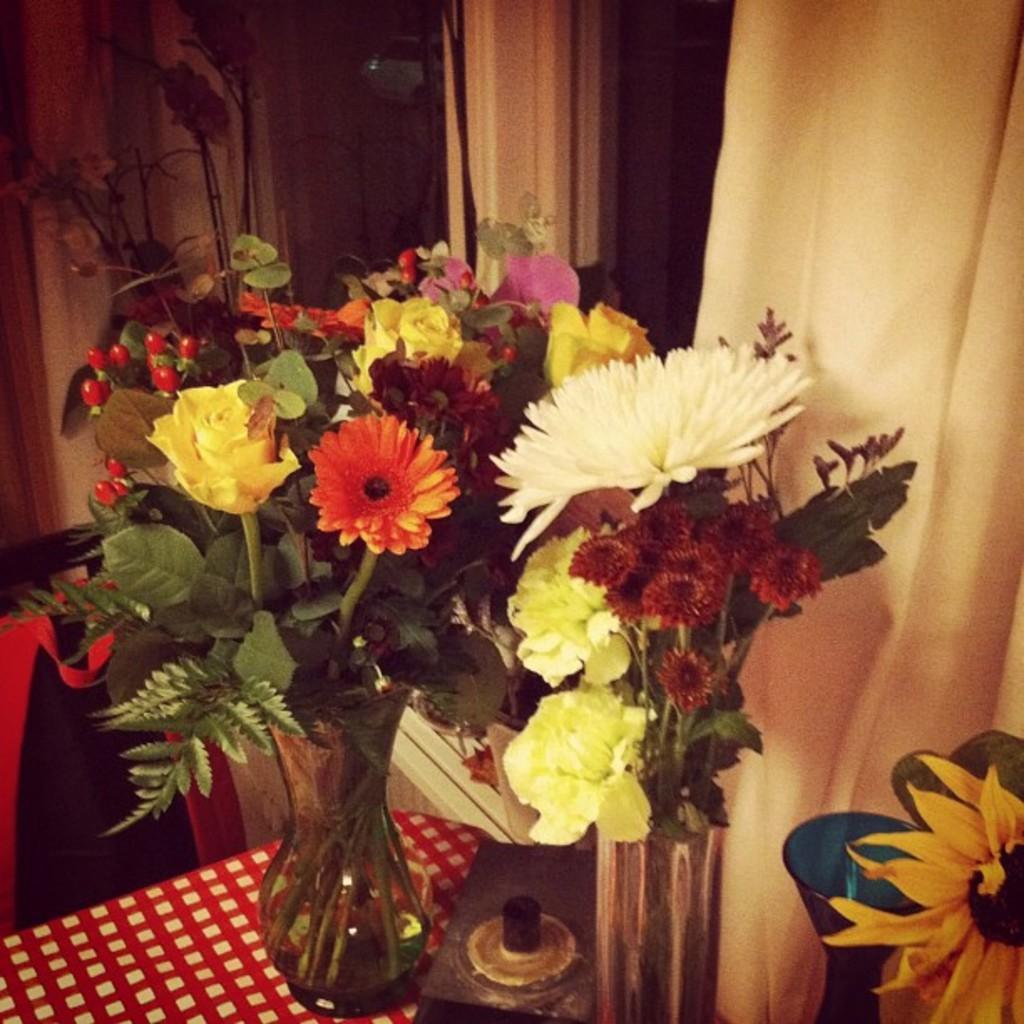Please provide a concise description of this image. In this image, we can see flower vases and object. Here we can see red and white surface. Background we can see glass window, curtains. 